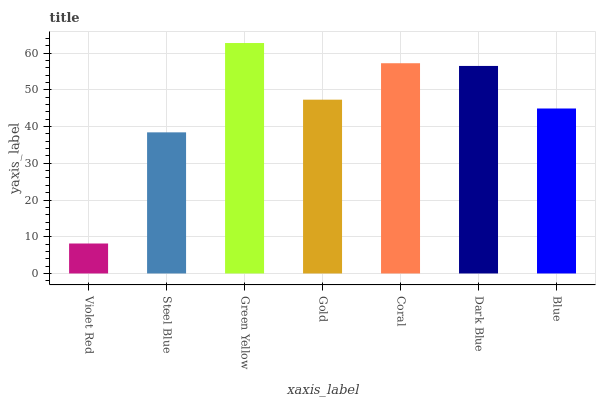Is Violet Red the minimum?
Answer yes or no. Yes. Is Green Yellow the maximum?
Answer yes or no. Yes. Is Steel Blue the minimum?
Answer yes or no. No. Is Steel Blue the maximum?
Answer yes or no. No. Is Steel Blue greater than Violet Red?
Answer yes or no. Yes. Is Violet Red less than Steel Blue?
Answer yes or no. Yes. Is Violet Red greater than Steel Blue?
Answer yes or no. No. Is Steel Blue less than Violet Red?
Answer yes or no. No. Is Gold the high median?
Answer yes or no. Yes. Is Gold the low median?
Answer yes or no. Yes. Is Coral the high median?
Answer yes or no. No. Is Steel Blue the low median?
Answer yes or no. No. 